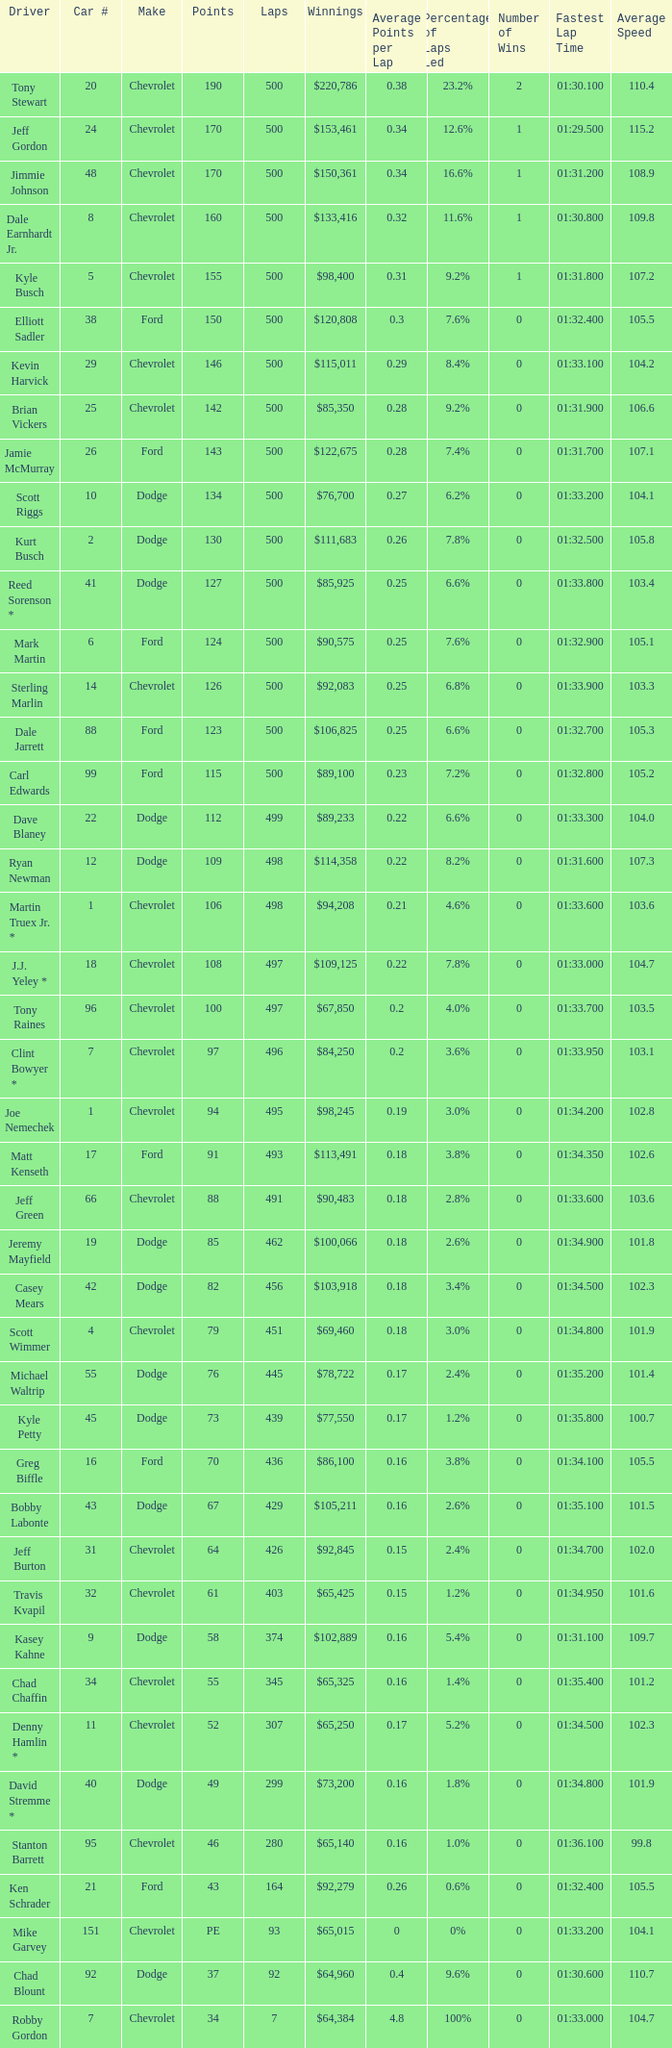What is the average car number of all the drivers with 109 points? 12.0. 